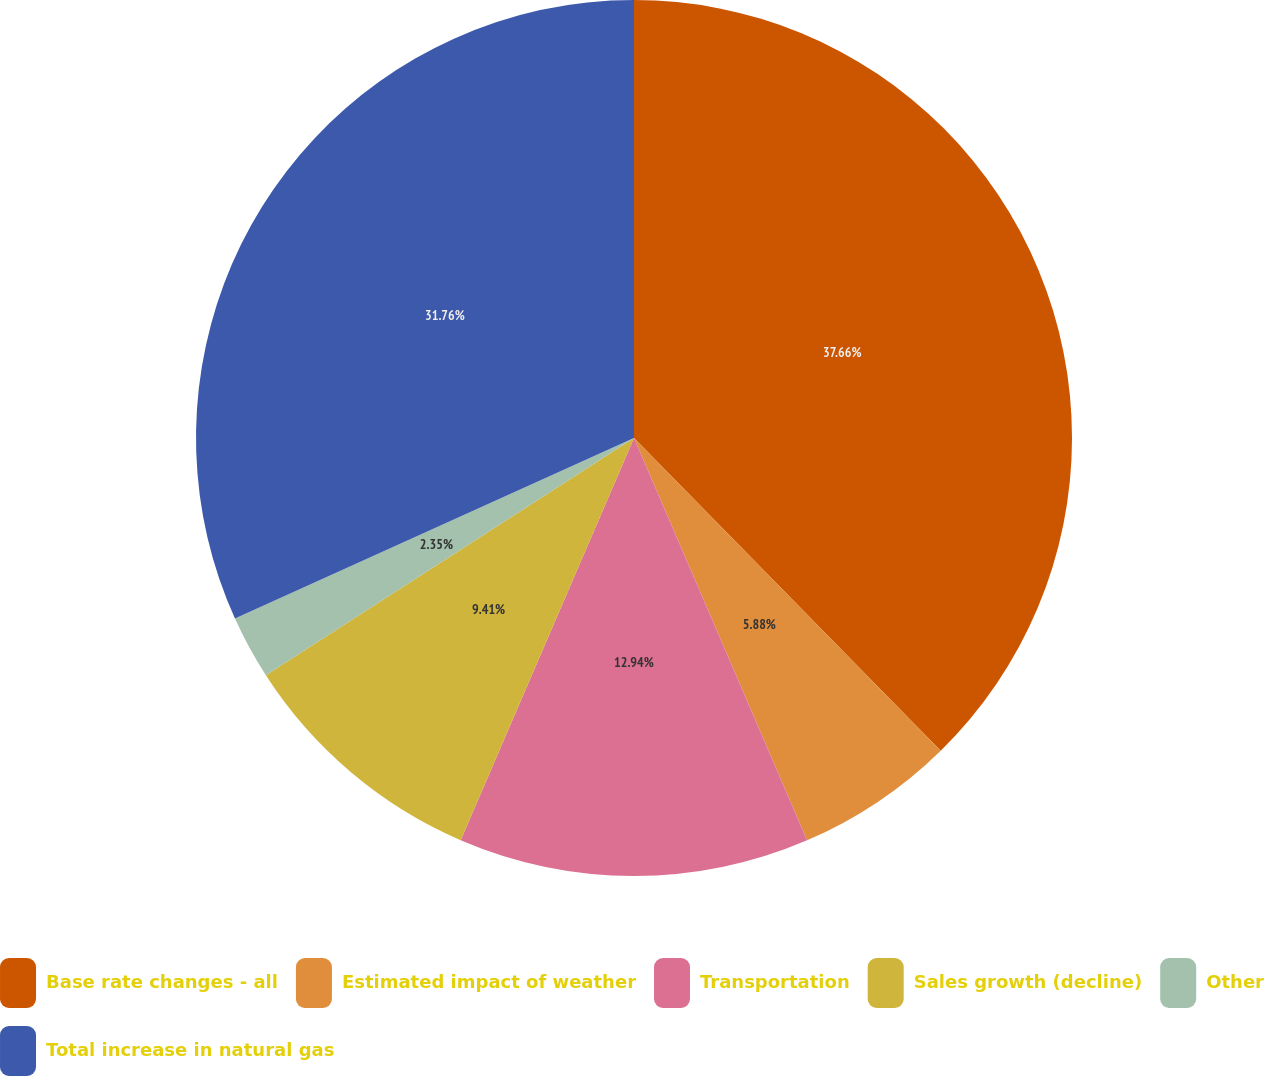Convert chart to OTSL. <chart><loc_0><loc_0><loc_500><loc_500><pie_chart><fcel>Base rate changes - all<fcel>Estimated impact of weather<fcel>Transportation<fcel>Sales growth (decline)<fcel>Other<fcel>Total increase in natural gas<nl><fcel>37.65%<fcel>5.88%<fcel>12.94%<fcel>9.41%<fcel>2.35%<fcel>31.76%<nl></chart> 